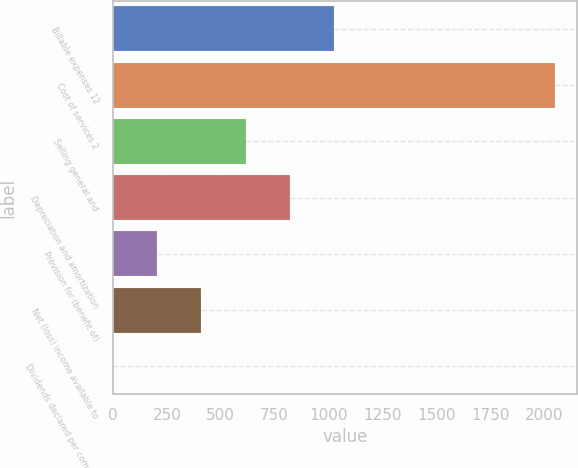Convert chart to OTSL. <chart><loc_0><loc_0><loc_500><loc_500><bar_chart><fcel>Billable expenses 12<fcel>Cost of services 2<fcel>Selling general and<fcel>Depreciation and amortization<fcel>Provision for (benefit of)<fcel>Net (loss) income available to<fcel>Dividends declared per common<nl><fcel>1024.71<fcel>2049.2<fcel>614.91<fcel>819.81<fcel>205.11<fcel>410.01<fcel>0.21<nl></chart> 